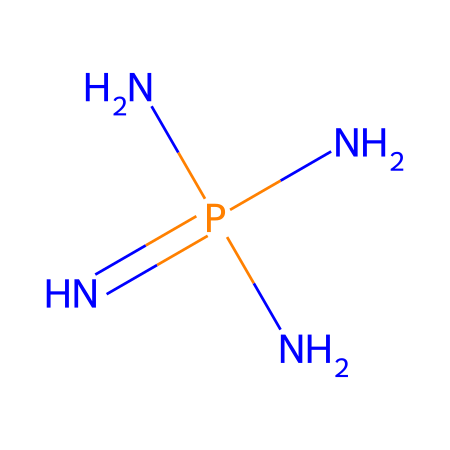What is the central atom in this structure? The central atom can be identified as the atom with the highest bonding capacity in the structure, which is phosphorus.
Answer: phosphorus How many nitrogen atoms are present in this chemical? The structure reveals four nitrogen atoms, as indicated by the "N" symbols surrounding the phosphorus atom.
Answer: four What type of bonding is primarily present in phosphazene? The structure indicates that it mainly involves covalent bonding, as shown by the connections between the nitrogen and phosphorus atoms without any charges.
Answer: covalent What could be a primary application of phosphazene due to its structure? Phosphazene's structure enhances its ability to create water-resistant coatings, making it suitable for such applications.
Answer: water-resistant coatings Is phosphazene a superbase? Yes, the structure indicates that it possesses basic characteristics due to the nitrogen atoms, which typically hold lone pairs that can accept protons.
Answer: yes What is the overall charge of this molecule? Analyzing the structure reveals that there are no formal charges on the atoms in this molecule, making its overall charge neutral.
Answer: neutral 